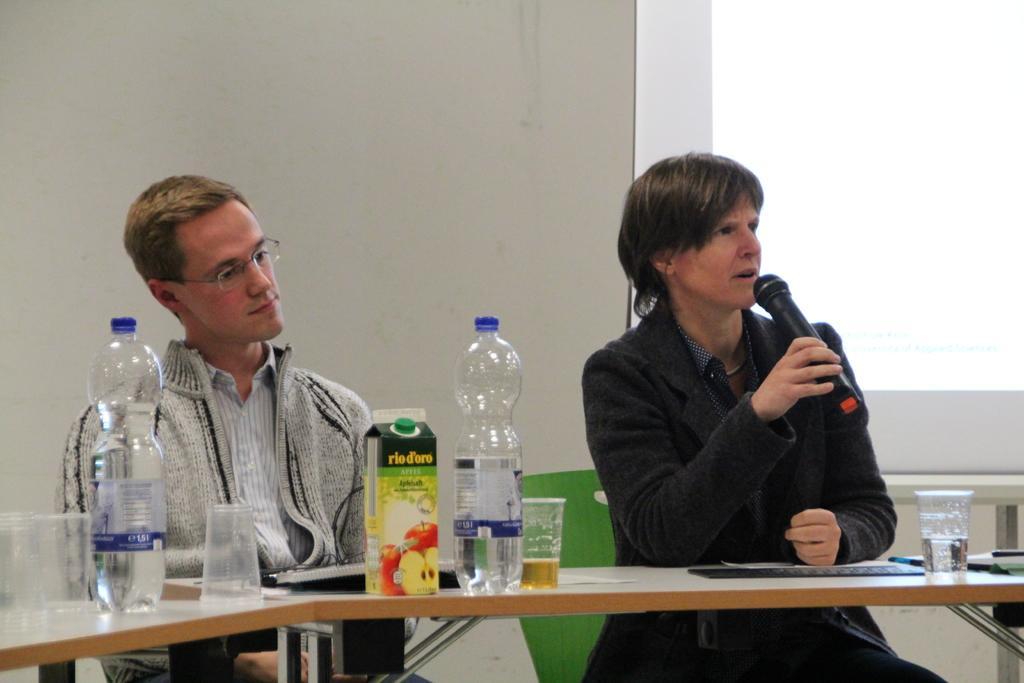Describe this image in one or two sentences. This picture is clicked inside the room. In the right corner of this picture, we see women wearing black jacket is holding microphone in her hands and talking on it. To the left corner of this picture, we see a man in white shirt wearing white jacket is sitting on the chair and he is also wearing spectacles. In front of them, we see a table on which glass, bottle, fruit juice is placed on it. Behind them, we see a wall which is white in color and beside that we see a window. 